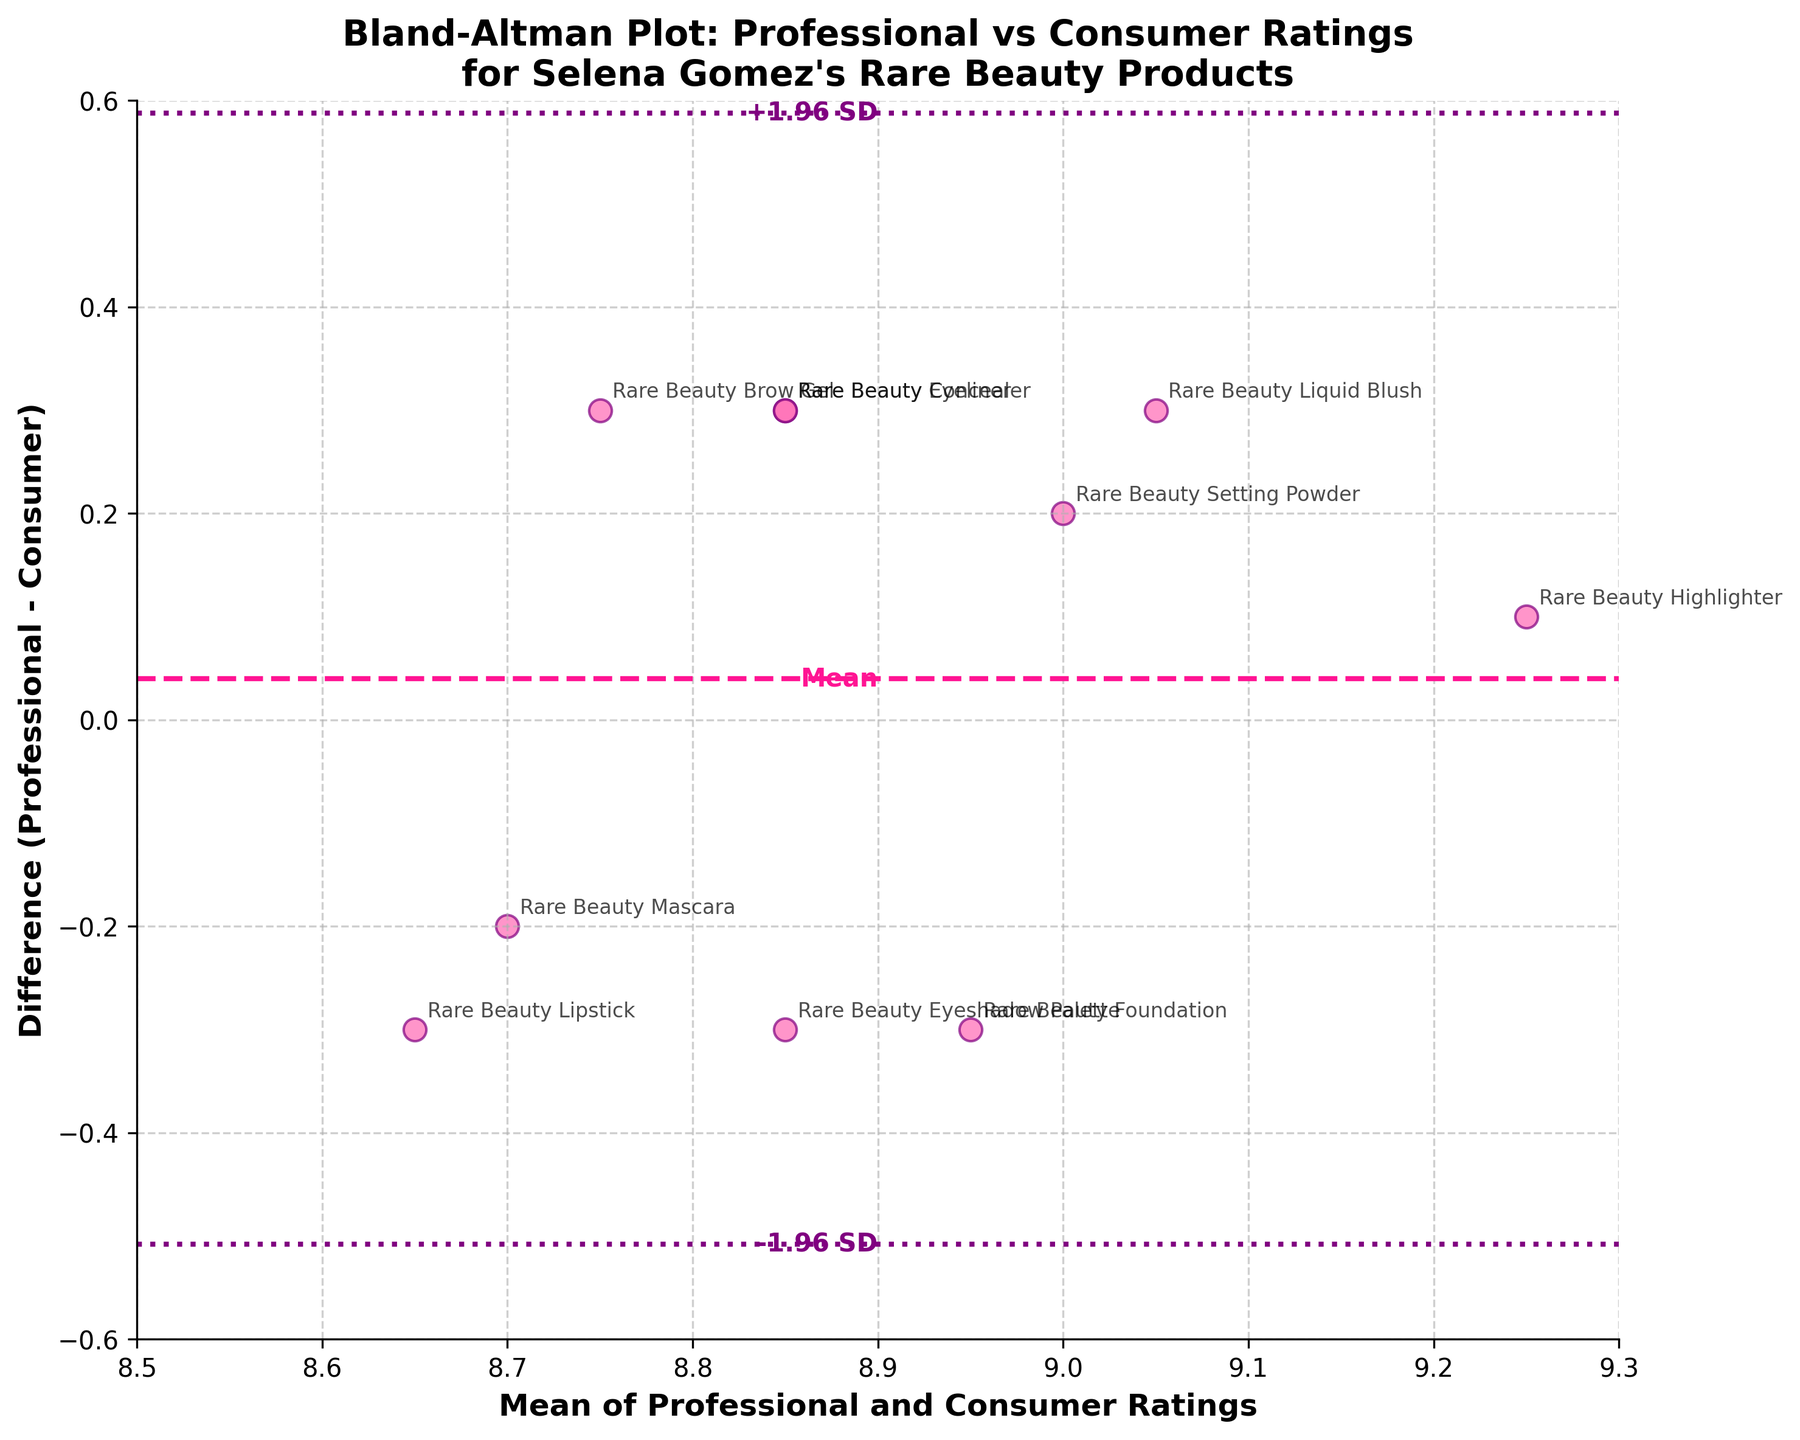How many data points are shown in the plot? The plot shows ten different Selena Gomez's Rare Beauty products. Each product is represented by a point on the plot. The products are labeled with their names next to the points.
Answer: Ten What is the mean difference (Professional - Consumer) as marked by a horizontal line? The mean difference is indicated by a horizontal dashed line labeled "Mean" on the plot. The value can be determined by its label or its position on the y-axis.
Answer: 0 Which product has the greatest positive difference (Professional - Consumer)? The product with the greatest positive difference is the one with the highest point on the y-axis. According to the plot, it is the one located at the highest point above the zero difference line.
Answer: Rare Beauty Foundation What's the range of the mean ratings on the x-axis? The x-axis shows the mean of professional and consumer ratings, ranging from 8.5 to 9.3. This can be observed from the axis labels.
Answer: 8.5 to 9.3 What are the upper and lower limits of agreement, and which products fall outside these limits? The upper and lower limits of agreement are shown as dotted lines labeled "+1.96 SD" and "-1.96 SD". To find which products fall outside these limits, we look for points outside these lines. There are no points outside these lines on the plot.
Answer: Upper: +0.38, Lower: -0.38, None fall outside Which product mean ratings around 8.9 show the highest absolute difference from zero? Look at the products with a mean rating around 8.9 on the x-axis, then check which corresponding points on the y-axis show the highest absolute value (distance from 0).
Answer: Rare Beauty Eyeliner and Rare Beauty Concealer Is there an overall trend regarding whether professional ratings are generally higher or lower than consumer ratings? By observing the distribution of points relative to the zero difference line, if most points are above the line, professional ratings are higher. If most points are below it, consumer ratings are higher. In this plot, the distribution is fairly even around the zero difference line.
Answer: No clear trend How many products have a professional rating exactly one shown to be higher than their consumer rating? Count the number of points that lie above the zero difference line (positive y-values) on the plot. These points indicate higher professional ratings.
Answer: Four What product has the closest professional and consumer rating? Look for the product closest to the zero difference line (y-axis), which means minimal difference between professional and consumer ratings.
Answer: Rare Beauty Highlighter 